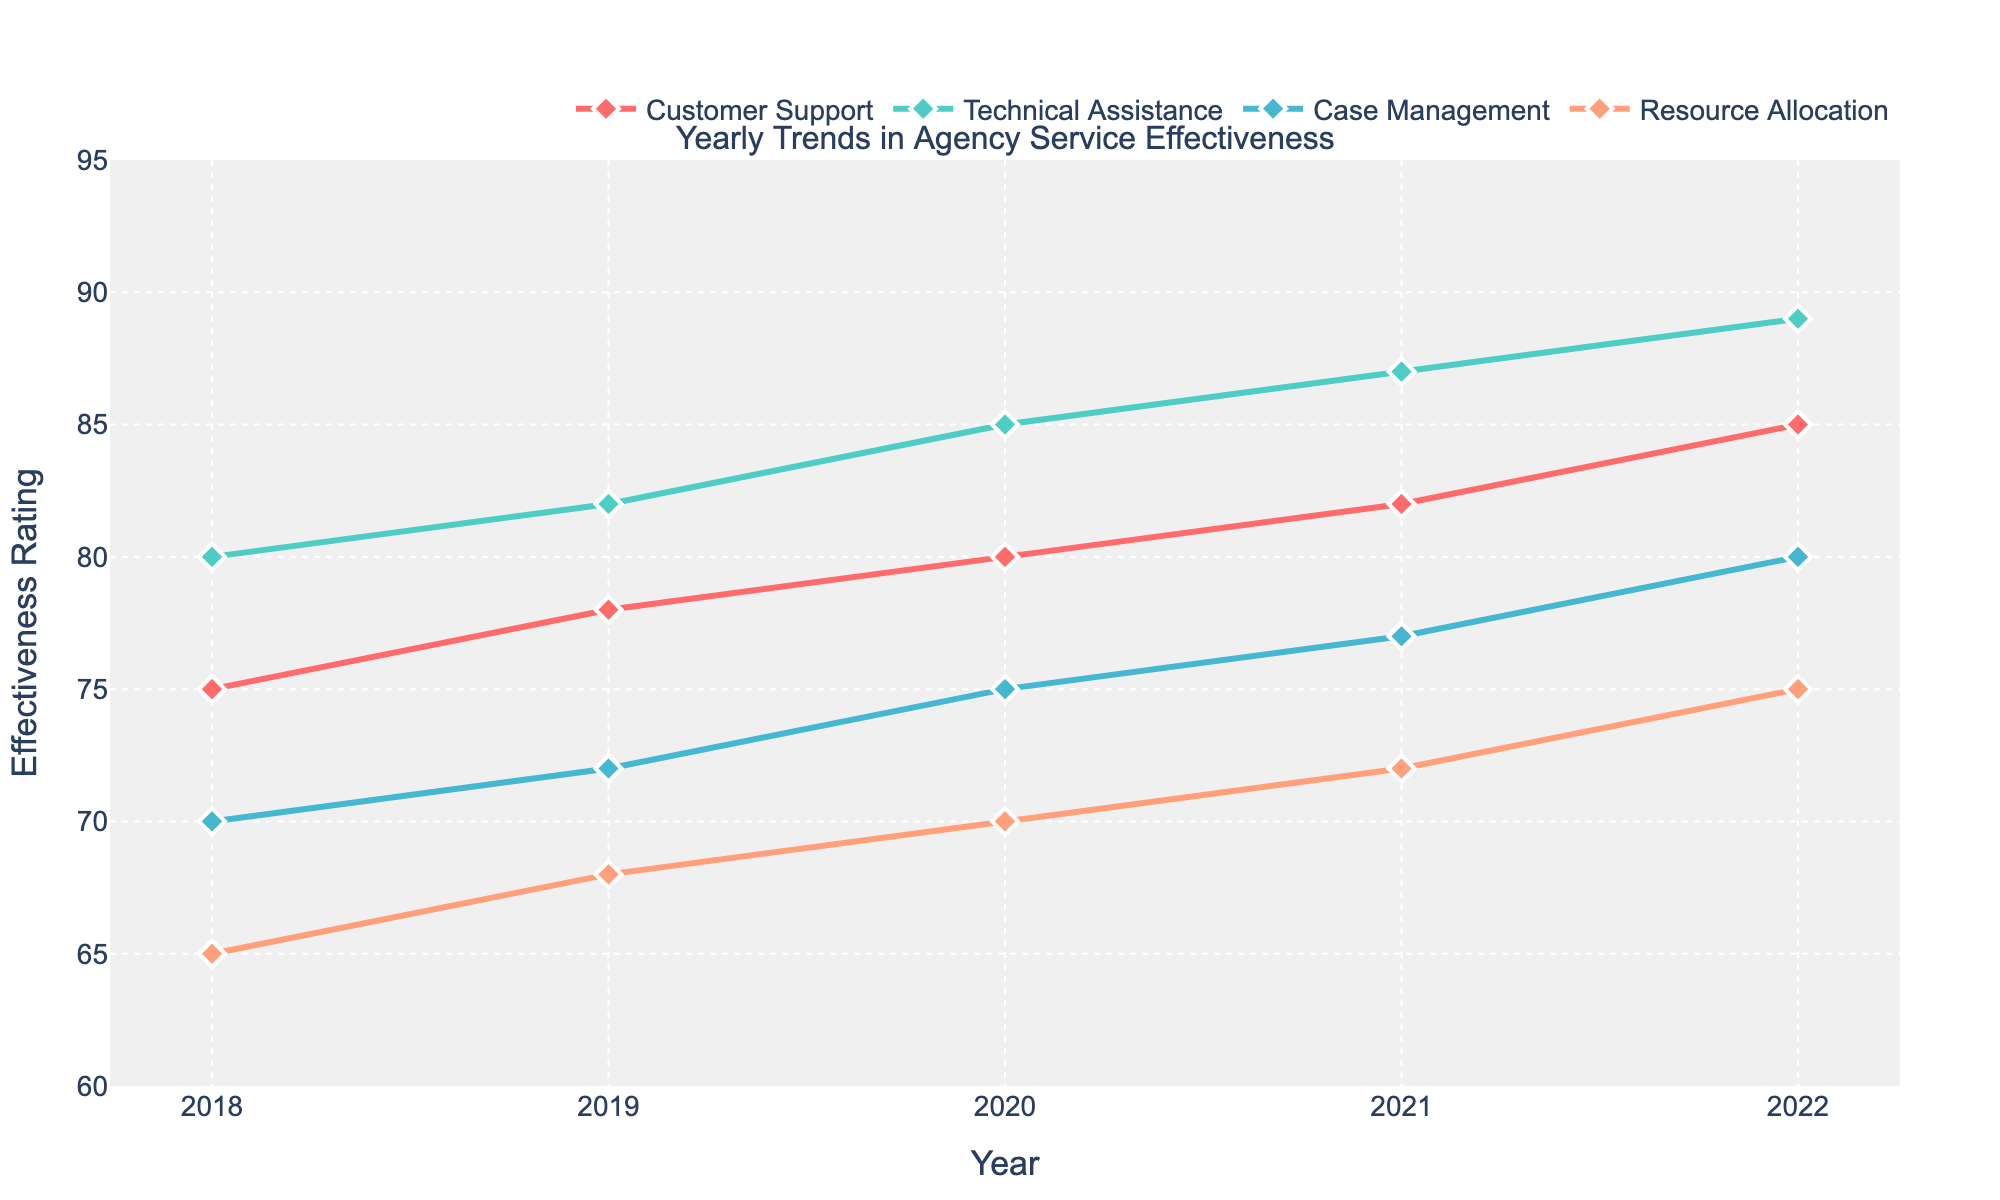What is the overall trend in the effectiveness rating for Customer Support over the years? Inspecting the plot for Customer Support, its trend line is increasing over the years from 75 in 2018 to 85 in 2022. This indicates a gradual improvement in the effectiveness of Customer Support.
Answer: Increasing How many services are displayed in the plot? There are four distinct lines in the plot, each representing a different service. Therefore, four services are displayed in the plot.
Answer: Four In which year did Technical Assistance receive the highest effectiveness rating? The plot shows that Technical Assistance had the highest effectiveness rating in 2022, reaching 89.
Answer: 2022 Which service has shown the least improvement in its effectiveness rating from 2018 to 2022? By examining the trend lines, Resource Allocation started at 65 in 2018 and increased to 75 by 2022. This is an improvement of 10 points, which is less than the improvements seen in Customer Support, Technical Assistance and Case Management.
Answer: Resource Allocation What is the average effectiveness rating of Case Management over the displayed years? The ratings for Case Management are: 70 (2018), 72 (2019), 75 (2020), 77 (2021), and 80 (2022). Adding these values gives 374. Dividing by 5 (the number of years) gives an average rating of 74.8.
Answer: 74.8 Which service had the highest effectiveness rating in 2018? Inspecting the plot, Technical Assistance had the highest effectiveness rating in 2018 at 80.
Answer: Technical Assistance Did any service have a declining effectiveness rating at any point in the years displayed? Reviewing the trend lines for each service from 2018 to 2022, none of them show a decline in effectiveness rating within the displayed years.
Answer: No How much did the effectiveness rating for Customer Support increase from 2020 to 2021? The rating for Customer Support increased from 80 in 2020 to 82 in 2021. The increase is 82 - 80 = 2 points.
Answer: 2 Which service has the most consistent trend over the years? Seeing that Technical Assistance has a steady and continuous increase without any fluctuations in its trend, it is the most consistent.
Answer: Technical Assistance Between Case Management and Resource Allocation, which improved more in effectiveness from 2019 to 2020 and by how much? Case Management improved from 72 to 75, an increase of 3 points, while Resource Allocation went from 68 to 70, an increase of 2 points. Therefore, Case Management improved more by 1 point.
Answer: Case Management, 1 point 